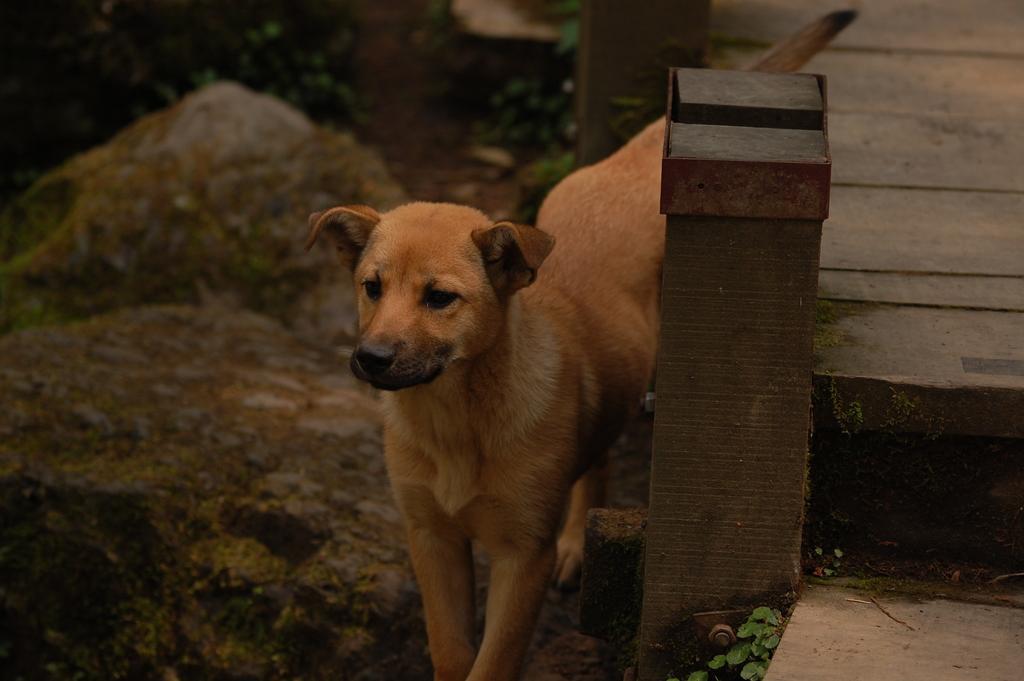Please provide a concise description of this image. In this image, we can see a dog standing on the surface. On the right side of the image, we can see plants, pole and walkway. In the background there are stones, plants and pole. 